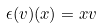<formula> <loc_0><loc_0><loc_500><loc_500>\epsilon ( v ) ( x ) = x v</formula> 